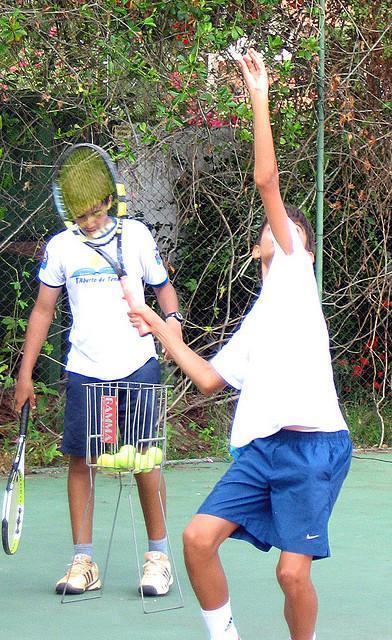How many people are there?
Give a very brief answer. 2. 